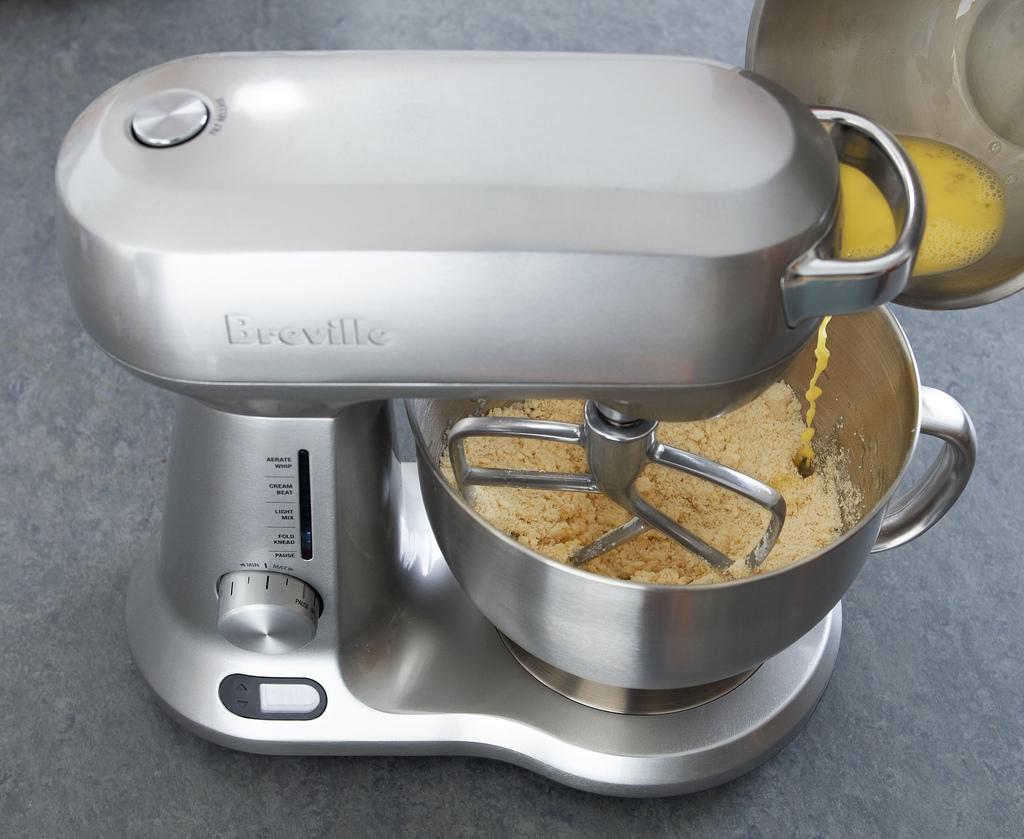What brand is this mixer?
Offer a very short reply. Breville. 